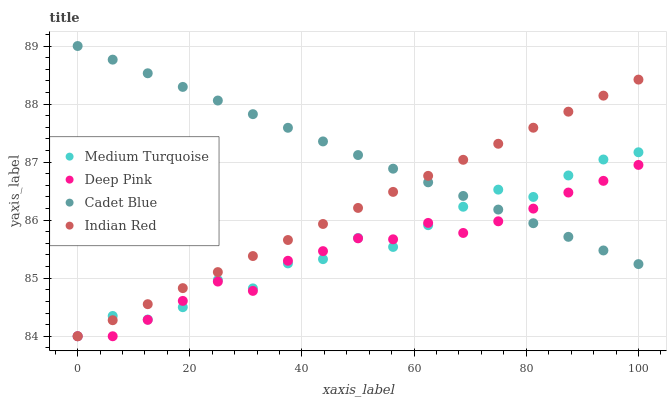Does Deep Pink have the minimum area under the curve?
Answer yes or no. Yes. Does Cadet Blue have the maximum area under the curve?
Answer yes or no. Yes. Does Indian Red have the minimum area under the curve?
Answer yes or no. No. Does Indian Red have the maximum area under the curve?
Answer yes or no. No. Is Indian Red the smoothest?
Answer yes or no. Yes. Is Medium Turquoise the roughest?
Answer yes or no. Yes. Is Deep Pink the smoothest?
Answer yes or no. No. Is Deep Pink the roughest?
Answer yes or no. No. Does Deep Pink have the lowest value?
Answer yes or no. Yes. Does Cadet Blue have the highest value?
Answer yes or no. Yes. Does Indian Red have the highest value?
Answer yes or no. No. Does Cadet Blue intersect Deep Pink?
Answer yes or no. Yes. Is Cadet Blue less than Deep Pink?
Answer yes or no. No. Is Cadet Blue greater than Deep Pink?
Answer yes or no. No. 